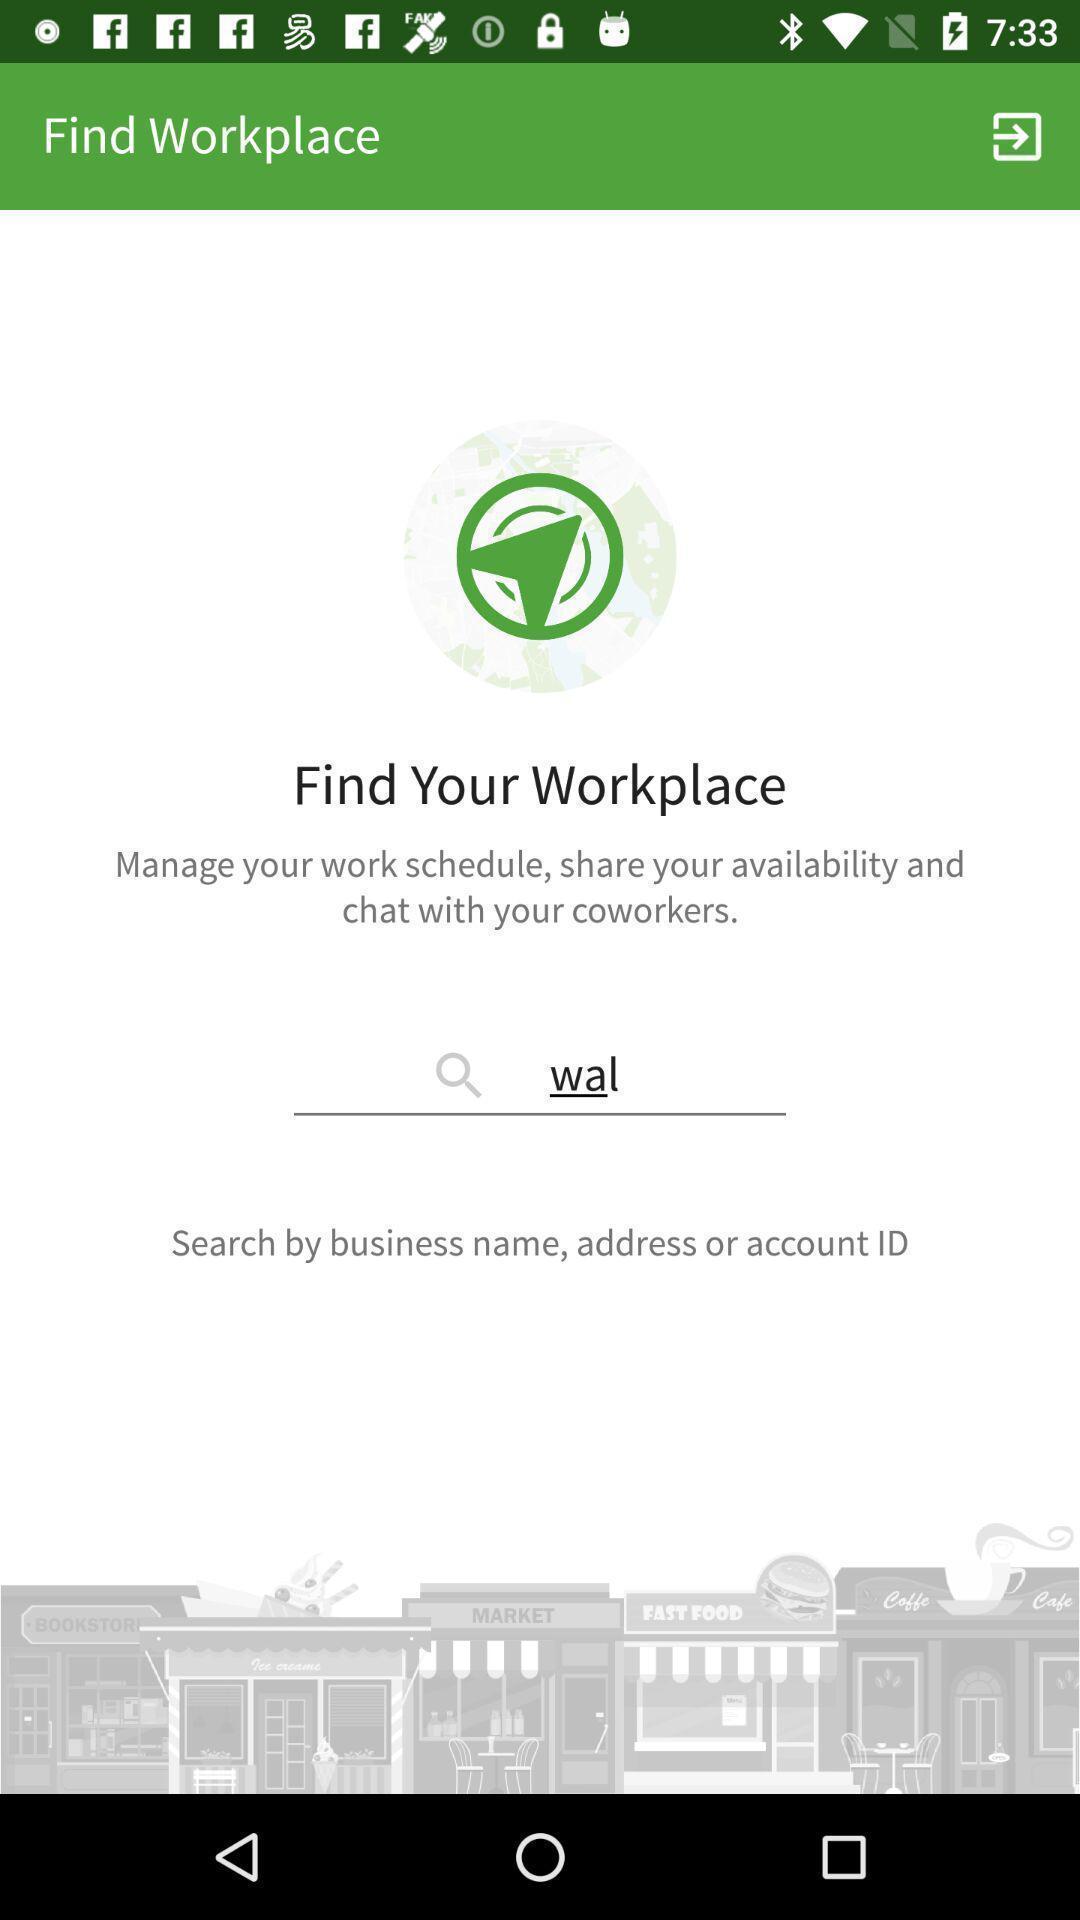What can you discern from this picture? Search bar to search workplace in app. 